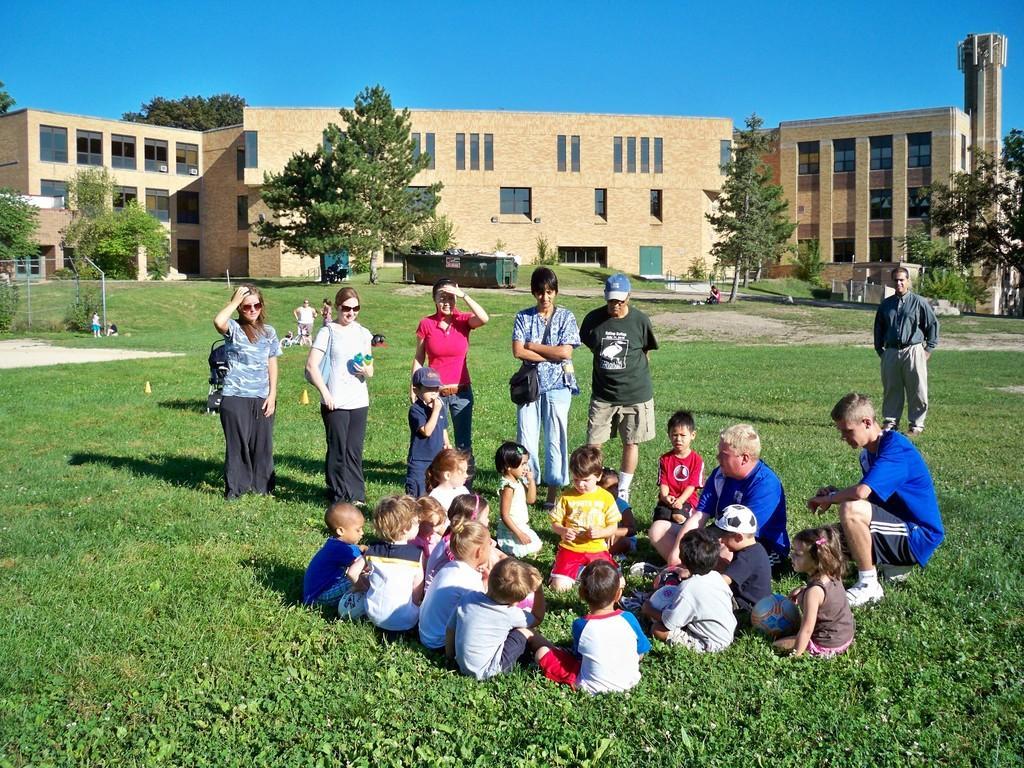Can you describe this image briefly? In this image I can see there are children's sitting on grass and some people standing on grass and at the top I can see the sky and in the middle I can see building ,in front of the building I can see trees and some container. 